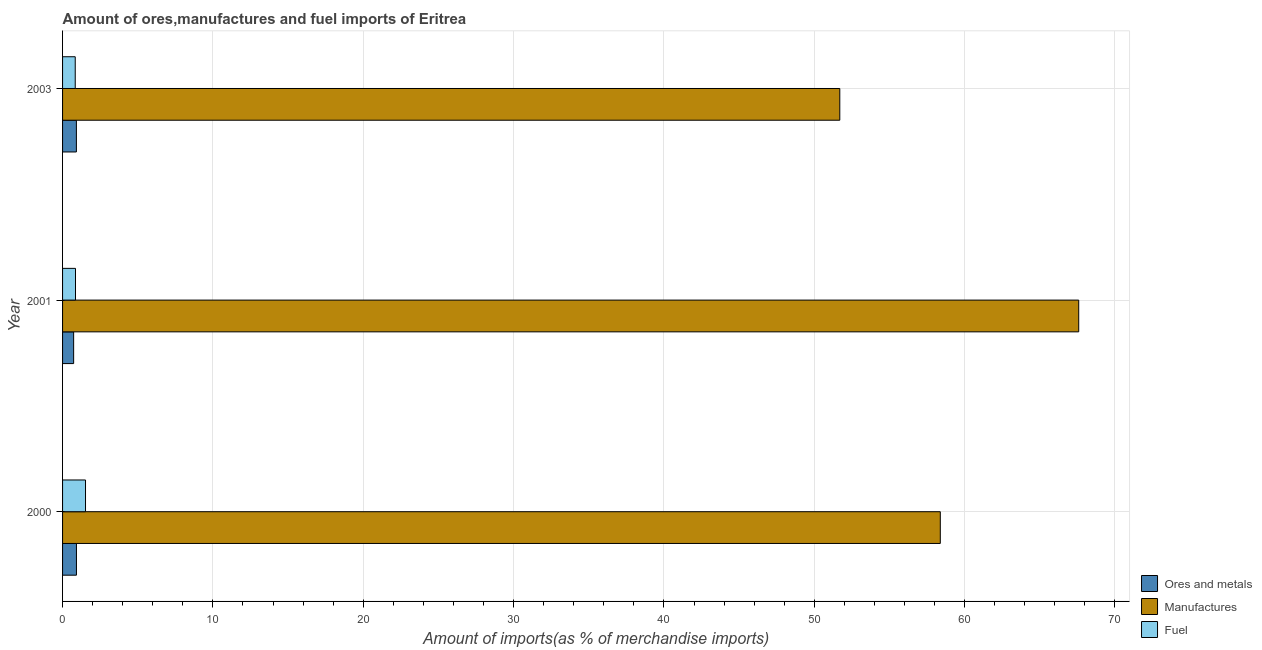How many different coloured bars are there?
Your answer should be very brief. 3. How many groups of bars are there?
Your response must be concise. 3. What is the percentage of manufactures imports in 2000?
Provide a short and direct response. 58.38. Across all years, what is the maximum percentage of fuel imports?
Your answer should be compact. 1.53. Across all years, what is the minimum percentage of fuel imports?
Provide a short and direct response. 0.84. In which year was the percentage of manufactures imports maximum?
Ensure brevity in your answer.  2001. In which year was the percentage of manufactures imports minimum?
Make the answer very short. 2003. What is the total percentage of ores and metals imports in the graph?
Provide a succinct answer. 2.58. What is the difference between the percentage of ores and metals imports in 2001 and that in 2003?
Ensure brevity in your answer.  -0.18. What is the difference between the percentage of manufactures imports in 2000 and the percentage of ores and metals imports in 2003?
Your answer should be very brief. 57.46. What is the average percentage of fuel imports per year?
Provide a succinct answer. 1.08. In the year 2000, what is the difference between the percentage of ores and metals imports and percentage of fuel imports?
Offer a terse response. -0.6. In how many years, is the percentage of ores and metals imports greater than 12 %?
Give a very brief answer. 0. What is the ratio of the percentage of fuel imports in 2000 to that in 2003?
Ensure brevity in your answer.  1.81. Is the percentage of fuel imports in 2000 less than that in 2003?
Keep it short and to the point. No. What is the difference between the highest and the second highest percentage of ores and metals imports?
Keep it short and to the point. 0. What is the difference between the highest and the lowest percentage of manufactures imports?
Offer a very short reply. 15.89. In how many years, is the percentage of ores and metals imports greater than the average percentage of ores and metals imports taken over all years?
Make the answer very short. 2. What does the 3rd bar from the top in 2000 represents?
Make the answer very short. Ores and metals. What does the 3rd bar from the bottom in 2001 represents?
Provide a short and direct response. Fuel. Are all the bars in the graph horizontal?
Your response must be concise. Yes. Does the graph contain grids?
Provide a succinct answer. Yes. Where does the legend appear in the graph?
Your answer should be very brief. Bottom right. What is the title of the graph?
Your response must be concise. Amount of ores,manufactures and fuel imports of Eritrea. What is the label or title of the X-axis?
Keep it short and to the point. Amount of imports(as % of merchandise imports). What is the label or title of the Y-axis?
Offer a terse response. Year. What is the Amount of imports(as % of merchandise imports) in Ores and metals in 2000?
Provide a succinct answer. 0.92. What is the Amount of imports(as % of merchandise imports) in Manufactures in 2000?
Your answer should be very brief. 58.38. What is the Amount of imports(as % of merchandise imports) in Fuel in 2000?
Provide a succinct answer. 1.53. What is the Amount of imports(as % of merchandise imports) of Ores and metals in 2001?
Offer a very short reply. 0.74. What is the Amount of imports(as % of merchandise imports) of Manufactures in 2001?
Make the answer very short. 67.59. What is the Amount of imports(as % of merchandise imports) in Fuel in 2001?
Your response must be concise. 0.86. What is the Amount of imports(as % of merchandise imports) in Ores and metals in 2003?
Give a very brief answer. 0.92. What is the Amount of imports(as % of merchandise imports) in Manufactures in 2003?
Give a very brief answer. 51.7. What is the Amount of imports(as % of merchandise imports) of Fuel in 2003?
Offer a terse response. 0.84. Across all years, what is the maximum Amount of imports(as % of merchandise imports) in Ores and metals?
Your answer should be compact. 0.92. Across all years, what is the maximum Amount of imports(as % of merchandise imports) of Manufactures?
Keep it short and to the point. 67.59. Across all years, what is the maximum Amount of imports(as % of merchandise imports) in Fuel?
Offer a very short reply. 1.53. Across all years, what is the minimum Amount of imports(as % of merchandise imports) of Ores and metals?
Provide a short and direct response. 0.74. Across all years, what is the minimum Amount of imports(as % of merchandise imports) in Manufactures?
Keep it short and to the point. 51.7. Across all years, what is the minimum Amount of imports(as % of merchandise imports) of Fuel?
Your answer should be very brief. 0.84. What is the total Amount of imports(as % of merchandise imports) of Ores and metals in the graph?
Ensure brevity in your answer.  2.58. What is the total Amount of imports(as % of merchandise imports) in Manufactures in the graph?
Give a very brief answer. 177.67. What is the total Amount of imports(as % of merchandise imports) in Fuel in the graph?
Keep it short and to the point. 3.23. What is the difference between the Amount of imports(as % of merchandise imports) of Ores and metals in 2000 and that in 2001?
Offer a terse response. 0.19. What is the difference between the Amount of imports(as % of merchandise imports) in Manufactures in 2000 and that in 2001?
Your answer should be very brief. -9.21. What is the difference between the Amount of imports(as % of merchandise imports) in Fuel in 2000 and that in 2001?
Ensure brevity in your answer.  0.67. What is the difference between the Amount of imports(as % of merchandise imports) in Ores and metals in 2000 and that in 2003?
Offer a terse response. 0. What is the difference between the Amount of imports(as % of merchandise imports) in Manufactures in 2000 and that in 2003?
Offer a terse response. 6.68. What is the difference between the Amount of imports(as % of merchandise imports) of Fuel in 2000 and that in 2003?
Make the answer very short. 0.68. What is the difference between the Amount of imports(as % of merchandise imports) in Ores and metals in 2001 and that in 2003?
Ensure brevity in your answer.  -0.18. What is the difference between the Amount of imports(as % of merchandise imports) of Manufactures in 2001 and that in 2003?
Offer a very short reply. 15.89. What is the difference between the Amount of imports(as % of merchandise imports) of Fuel in 2001 and that in 2003?
Provide a short and direct response. 0.02. What is the difference between the Amount of imports(as % of merchandise imports) of Ores and metals in 2000 and the Amount of imports(as % of merchandise imports) of Manufactures in 2001?
Provide a short and direct response. -66.66. What is the difference between the Amount of imports(as % of merchandise imports) of Ores and metals in 2000 and the Amount of imports(as % of merchandise imports) of Fuel in 2001?
Your response must be concise. 0.06. What is the difference between the Amount of imports(as % of merchandise imports) of Manufactures in 2000 and the Amount of imports(as % of merchandise imports) of Fuel in 2001?
Keep it short and to the point. 57.52. What is the difference between the Amount of imports(as % of merchandise imports) of Ores and metals in 2000 and the Amount of imports(as % of merchandise imports) of Manufactures in 2003?
Provide a succinct answer. -50.77. What is the difference between the Amount of imports(as % of merchandise imports) of Ores and metals in 2000 and the Amount of imports(as % of merchandise imports) of Fuel in 2003?
Provide a succinct answer. 0.08. What is the difference between the Amount of imports(as % of merchandise imports) of Manufactures in 2000 and the Amount of imports(as % of merchandise imports) of Fuel in 2003?
Keep it short and to the point. 57.54. What is the difference between the Amount of imports(as % of merchandise imports) in Ores and metals in 2001 and the Amount of imports(as % of merchandise imports) in Manufactures in 2003?
Your answer should be very brief. -50.96. What is the difference between the Amount of imports(as % of merchandise imports) in Ores and metals in 2001 and the Amount of imports(as % of merchandise imports) in Fuel in 2003?
Provide a succinct answer. -0.11. What is the difference between the Amount of imports(as % of merchandise imports) of Manufactures in 2001 and the Amount of imports(as % of merchandise imports) of Fuel in 2003?
Provide a succinct answer. 66.75. What is the average Amount of imports(as % of merchandise imports) in Ores and metals per year?
Ensure brevity in your answer.  0.86. What is the average Amount of imports(as % of merchandise imports) of Manufactures per year?
Ensure brevity in your answer.  59.22. What is the average Amount of imports(as % of merchandise imports) in Fuel per year?
Your response must be concise. 1.08. In the year 2000, what is the difference between the Amount of imports(as % of merchandise imports) of Ores and metals and Amount of imports(as % of merchandise imports) of Manufactures?
Give a very brief answer. -57.46. In the year 2000, what is the difference between the Amount of imports(as % of merchandise imports) in Ores and metals and Amount of imports(as % of merchandise imports) in Fuel?
Give a very brief answer. -0.6. In the year 2000, what is the difference between the Amount of imports(as % of merchandise imports) in Manufactures and Amount of imports(as % of merchandise imports) in Fuel?
Your response must be concise. 56.85. In the year 2001, what is the difference between the Amount of imports(as % of merchandise imports) in Ores and metals and Amount of imports(as % of merchandise imports) in Manufactures?
Provide a short and direct response. -66.85. In the year 2001, what is the difference between the Amount of imports(as % of merchandise imports) in Ores and metals and Amount of imports(as % of merchandise imports) in Fuel?
Ensure brevity in your answer.  -0.12. In the year 2001, what is the difference between the Amount of imports(as % of merchandise imports) of Manufactures and Amount of imports(as % of merchandise imports) of Fuel?
Ensure brevity in your answer.  66.73. In the year 2003, what is the difference between the Amount of imports(as % of merchandise imports) in Ores and metals and Amount of imports(as % of merchandise imports) in Manufactures?
Offer a terse response. -50.78. In the year 2003, what is the difference between the Amount of imports(as % of merchandise imports) in Ores and metals and Amount of imports(as % of merchandise imports) in Fuel?
Keep it short and to the point. 0.08. In the year 2003, what is the difference between the Amount of imports(as % of merchandise imports) in Manufactures and Amount of imports(as % of merchandise imports) in Fuel?
Provide a succinct answer. 50.85. What is the ratio of the Amount of imports(as % of merchandise imports) in Ores and metals in 2000 to that in 2001?
Offer a terse response. 1.25. What is the ratio of the Amount of imports(as % of merchandise imports) of Manufactures in 2000 to that in 2001?
Provide a short and direct response. 0.86. What is the ratio of the Amount of imports(as % of merchandise imports) of Fuel in 2000 to that in 2001?
Keep it short and to the point. 1.77. What is the ratio of the Amount of imports(as % of merchandise imports) in Manufactures in 2000 to that in 2003?
Offer a terse response. 1.13. What is the ratio of the Amount of imports(as % of merchandise imports) of Fuel in 2000 to that in 2003?
Your response must be concise. 1.81. What is the ratio of the Amount of imports(as % of merchandise imports) in Ores and metals in 2001 to that in 2003?
Provide a succinct answer. 0.8. What is the ratio of the Amount of imports(as % of merchandise imports) in Manufactures in 2001 to that in 2003?
Offer a terse response. 1.31. What is the ratio of the Amount of imports(as % of merchandise imports) of Fuel in 2001 to that in 2003?
Provide a short and direct response. 1.02. What is the difference between the highest and the second highest Amount of imports(as % of merchandise imports) in Ores and metals?
Your answer should be compact. 0. What is the difference between the highest and the second highest Amount of imports(as % of merchandise imports) in Manufactures?
Provide a succinct answer. 9.21. What is the difference between the highest and the second highest Amount of imports(as % of merchandise imports) in Fuel?
Keep it short and to the point. 0.67. What is the difference between the highest and the lowest Amount of imports(as % of merchandise imports) of Ores and metals?
Keep it short and to the point. 0.19. What is the difference between the highest and the lowest Amount of imports(as % of merchandise imports) of Manufactures?
Offer a very short reply. 15.89. What is the difference between the highest and the lowest Amount of imports(as % of merchandise imports) of Fuel?
Give a very brief answer. 0.68. 